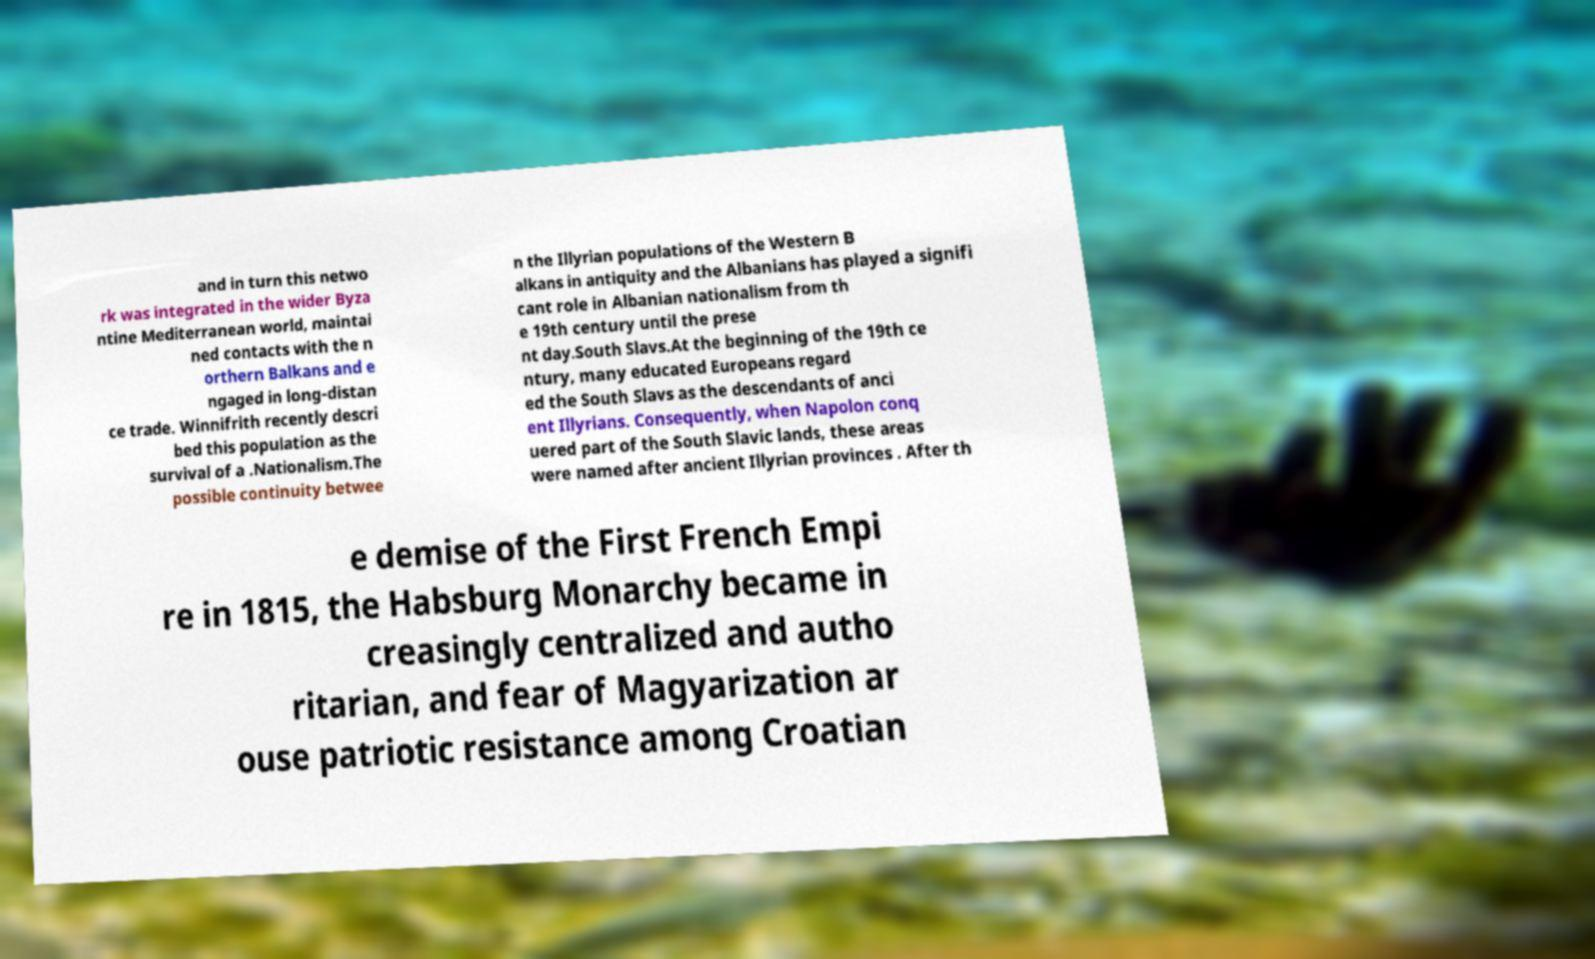Please identify and transcribe the text found in this image. and in turn this netwo rk was integrated in the wider Byza ntine Mediterranean world, maintai ned contacts with the n orthern Balkans and e ngaged in long-distan ce trade. Winnifrith recently descri bed this population as the survival of a .Nationalism.The possible continuity betwee n the Illyrian populations of the Western B alkans in antiquity and the Albanians has played a signifi cant role in Albanian nationalism from th e 19th century until the prese nt day.South Slavs.At the beginning of the 19th ce ntury, many educated Europeans regard ed the South Slavs as the descendants of anci ent Illyrians. Consequently, when Napolon conq uered part of the South Slavic lands, these areas were named after ancient Illyrian provinces . After th e demise of the First French Empi re in 1815, the Habsburg Monarchy became in creasingly centralized and autho ritarian, and fear of Magyarization ar ouse patriotic resistance among Croatian 